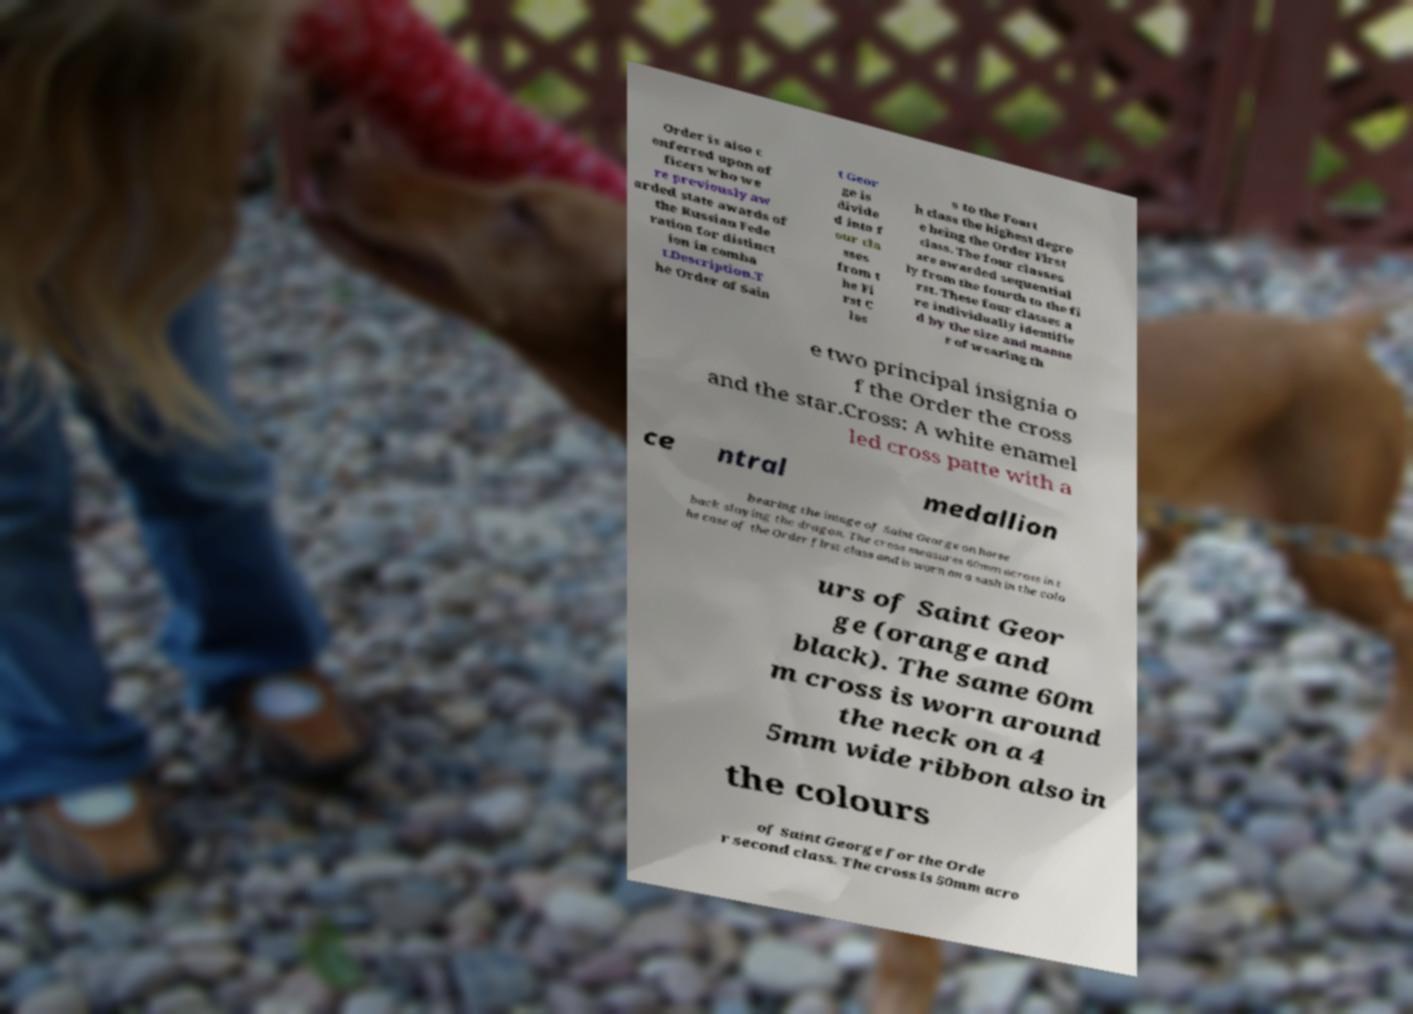Could you extract and type out the text from this image? Order is also c onferred upon of ficers who we re previously aw arded state awards of the Russian Fede ration for distinct ion in comba t.Description.T he Order of Sain t Geor ge is divide d into f our cla sses from t he Fi rst C las s to the Fourt h class the highest degre e being the Order First class. The four classes are awarded sequential ly from the fourth to the fi rst. These four classes a re individually identifie d by the size and manne r of wearing th e two principal insignia o f the Order the cross and the star.Cross: A white enamel led cross patte with a ce ntral medallion bearing the image of Saint George on horse back slaying the dragon. The cross measures 60mm across in t he case of the Order first class and is worn on a sash in the colo urs of Saint Geor ge (orange and black). The same 60m m cross is worn around the neck on a 4 5mm wide ribbon also in the colours of Saint George for the Orde r second class. The cross is 50mm acro 